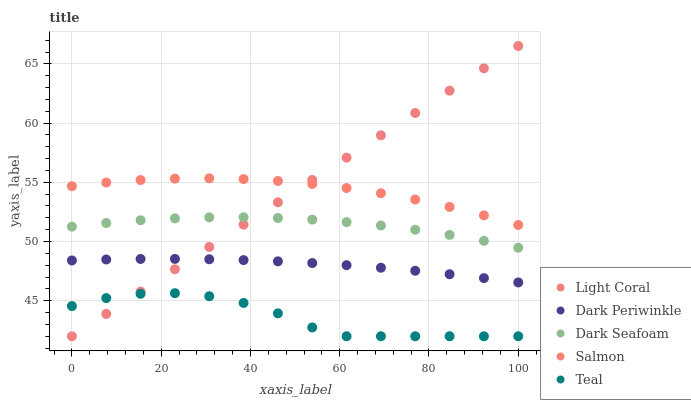Does Teal have the minimum area under the curve?
Answer yes or no. Yes. Does Salmon have the maximum area under the curve?
Answer yes or no. Yes. Does Dark Seafoam have the minimum area under the curve?
Answer yes or no. No. Does Dark Seafoam have the maximum area under the curve?
Answer yes or no. No. Is Light Coral the smoothest?
Answer yes or no. Yes. Is Teal the roughest?
Answer yes or no. Yes. Is Dark Seafoam the smoothest?
Answer yes or no. No. Is Dark Seafoam the roughest?
Answer yes or no. No. Does Light Coral have the lowest value?
Answer yes or no. Yes. Does Dark Seafoam have the lowest value?
Answer yes or no. No. Does Light Coral have the highest value?
Answer yes or no. Yes. Does Dark Seafoam have the highest value?
Answer yes or no. No. Is Teal less than Dark Seafoam?
Answer yes or no. Yes. Is Salmon greater than Dark Seafoam?
Answer yes or no. Yes. Does Light Coral intersect Dark Periwinkle?
Answer yes or no. Yes. Is Light Coral less than Dark Periwinkle?
Answer yes or no. No. Is Light Coral greater than Dark Periwinkle?
Answer yes or no. No. Does Teal intersect Dark Seafoam?
Answer yes or no. No. 